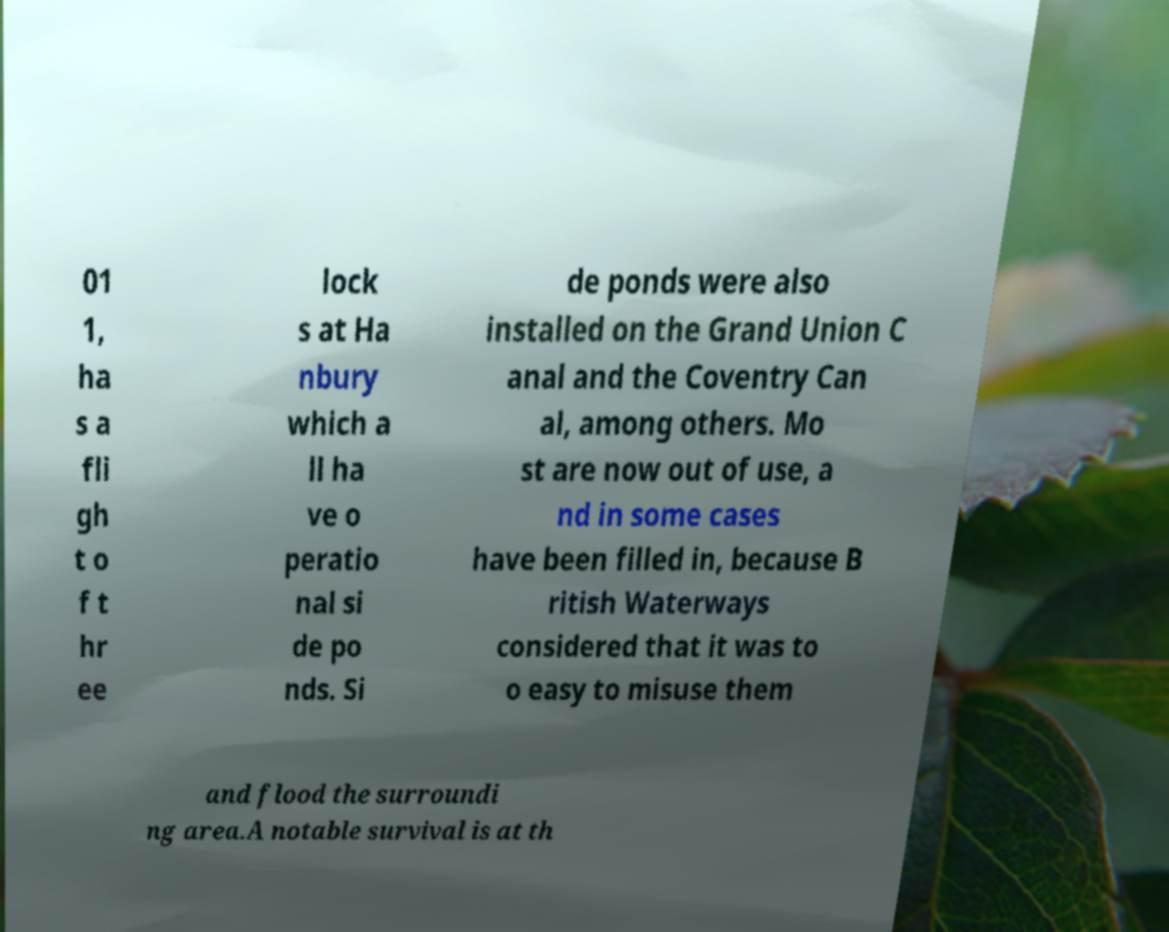Please identify and transcribe the text found in this image. 01 1, ha s a fli gh t o f t hr ee lock s at Ha nbury which a ll ha ve o peratio nal si de po nds. Si de ponds were also installed on the Grand Union C anal and the Coventry Can al, among others. Mo st are now out of use, a nd in some cases have been filled in, because B ritish Waterways considered that it was to o easy to misuse them and flood the surroundi ng area.A notable survival is at th 